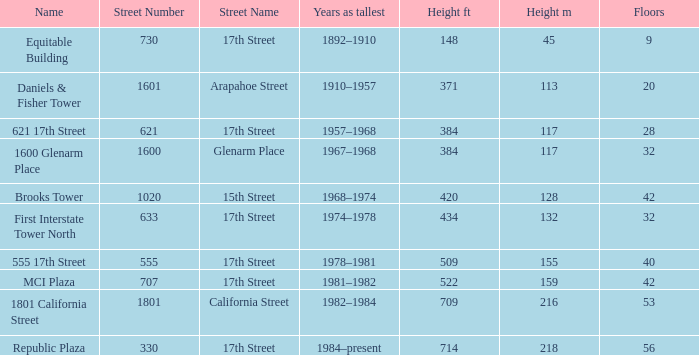What is the height of the building named 555 17th street? 509 / 155. 